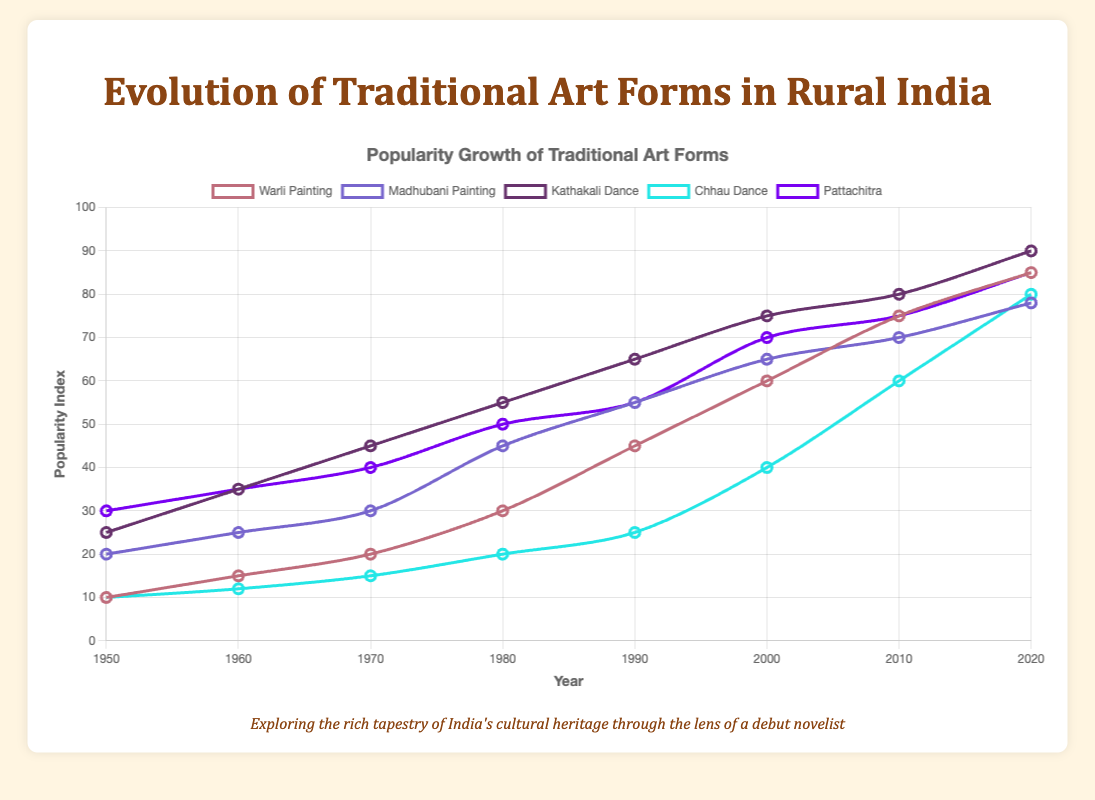What's the trend in the popularity of Warli Painting from 1950 to 2020? To find the trend, look at the points representing Warli Painting from 1950 to 2020. The popularity index increases steadily from 10 in 1950 to 85 in 2020, showing a significant upward trend.
Answer: Upward trend Which art form had the highest popularity index in 1980? Identify the popularity indices for each art form in 1980: Warli Painting (30), Madhubani Painting (45), Kathakali Dance (55), Chhau Dance (20), and Pattachitra (50). The highest value is for Kathakali Dance.
Answer: Kathakali Dance Considering the year 2000, arrange the art forms in descending order of their popularity index. Look at the popularity indices for the year 2000: Warli Painting (60), Madhubani Painting (65), Kathakali Dance (75), Chhau Dance (40), and Pattachitra (70). In descending order: Kathakali Dance, Pattachitra, Madhubani Painting, Warli Painting, Chhau Dance.
Answer: Kathakali Dance, Pattachitra, Madhubani Painting, Warli Painting, Chhau Dance Between 1990 and 2010, which art form exhibited the steepest increase in popularity? Check the popularity indices for 1990 and 2010. Warli Painting increased from 45 to 75 (30 points), Madhubani Painting from 55 to 70 (15 points), Kathakali Dance from 65 to 80 (15 points), Chhau Dance from 25 to 60 (35 points), and Pattachitra from 55 to 75 (20 points). Chhau Dance had the steepest increase.
Answer: Chhau Dance Which two art forms had an overlapping popularity index value at any year, and what was that value? Cross-check the popularity index values for overlaps: Pattachitra and Warli Painting both had a popularity index of 85 in 2020.
Answer: Pattachitra and Warli Painting, 85 How much did the popularity index increase for Chhau Dance from 1950 to 2000? Note the values: Chhau Dance had an index of 10 in 1950 and 40 in 2000. The increase is 40 - 10 = 30.
Answer: 30 What is the average popularity index of Madhubani Painting across the decades shown? Sum the popularity indices: 20, 25, 30, 45, 55, 65, 70, 78 = 388. Count the decades: 8. Calculate the average: 388 / 8 = 48.5.
Answer: 48.5 Which art form showed the least growth in popularity between 1950 and 2020? Calculate the popularity growth for each art form from 1950 to 2020: Warli Painting (85-10=75), Madhubani Painting (78-20=58), Kathakali Dance (90-25=65), Chhau Dance (80-10=70), and Pattachitra (85-30=55). The least growth is for Madhubani Painting (58).
Answer: Madhubani Painting 